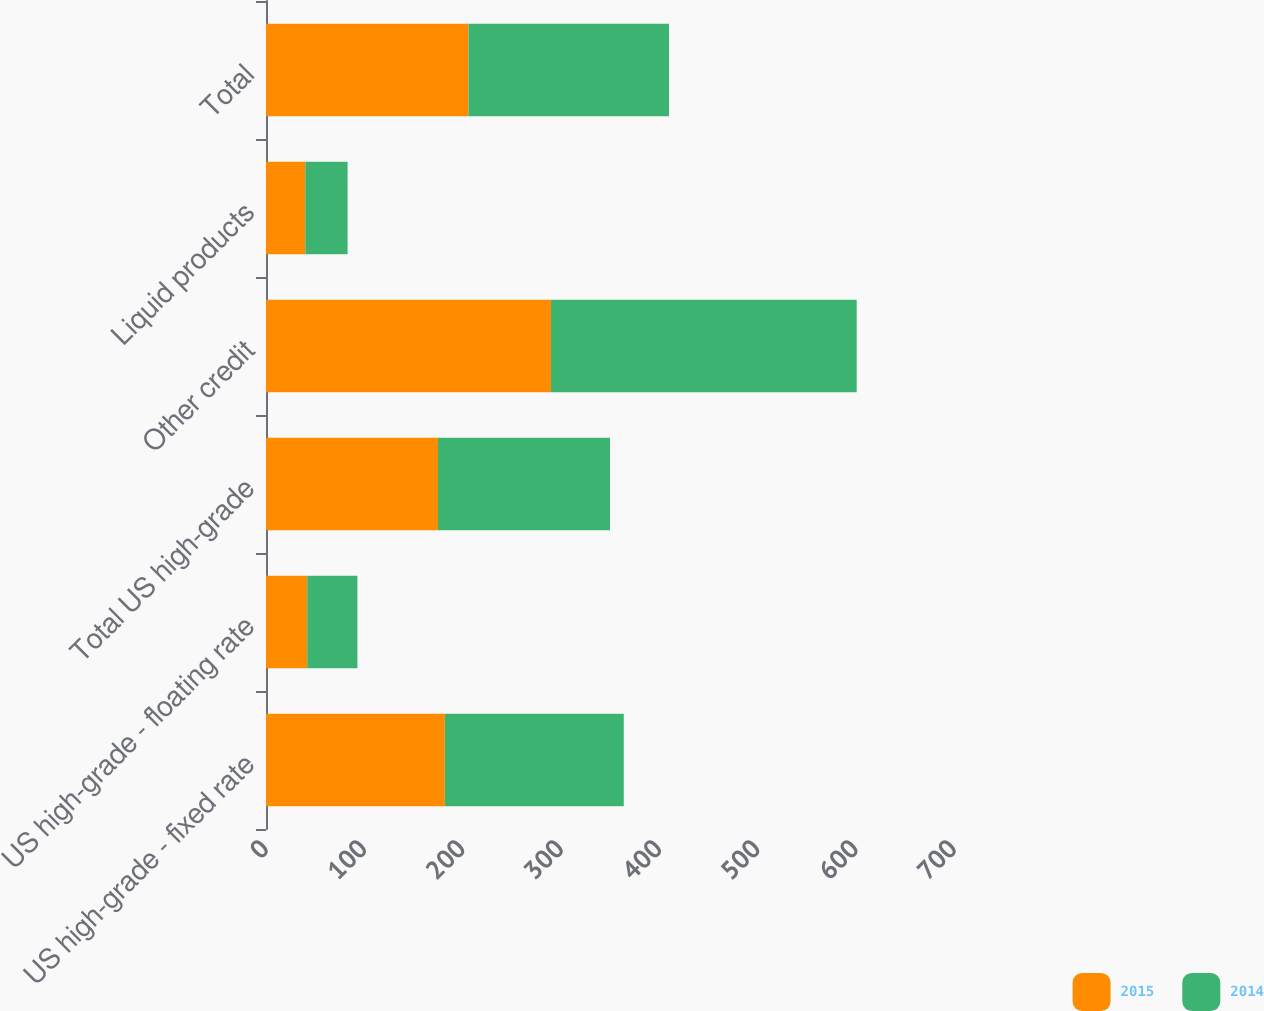Convert chart to OTSL. <chart><loc_0><loc_0><loc_500><loc_500><stacked_bar_chart><ecel><fcel>US high-grade - fixed rate<fcel>US high-grade - floating rate<fcel>Total US high-grade<fcel>Other credit<fcel>Liquid products<fcel>Total<nl><fcel>2015<fcel>182<fcel>42<fcel>175<fcel>290<fcel>40<fcel>206<nl><fcel>2014<fcel>182<fcel>51<fcel>175<fcel>311<fcel>43<fcel>204<nl></chart> 